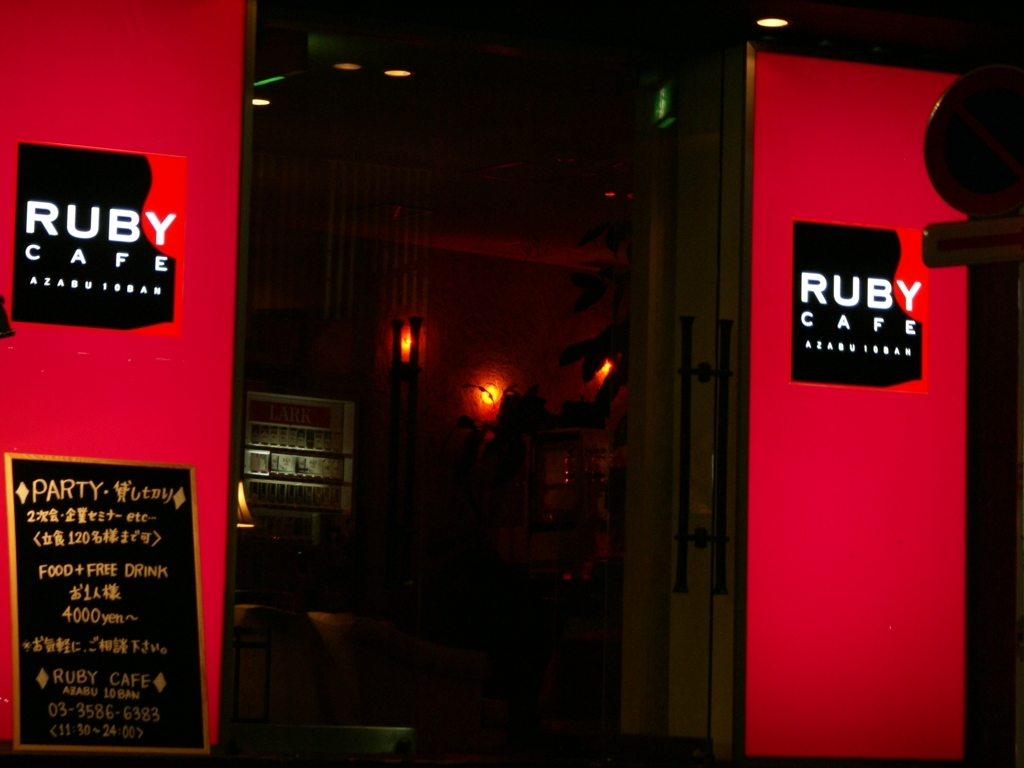What kind of atmosphere does the image convey about the place it represents? The image conveys a cozy and warm atmosphere, highlighted by the glowing red and amber lights. The 'RUBY CAFE' sign evokes a feeling of a lively social spot, likely to attract evening patrons looking for a vibrant, intimate setting. 